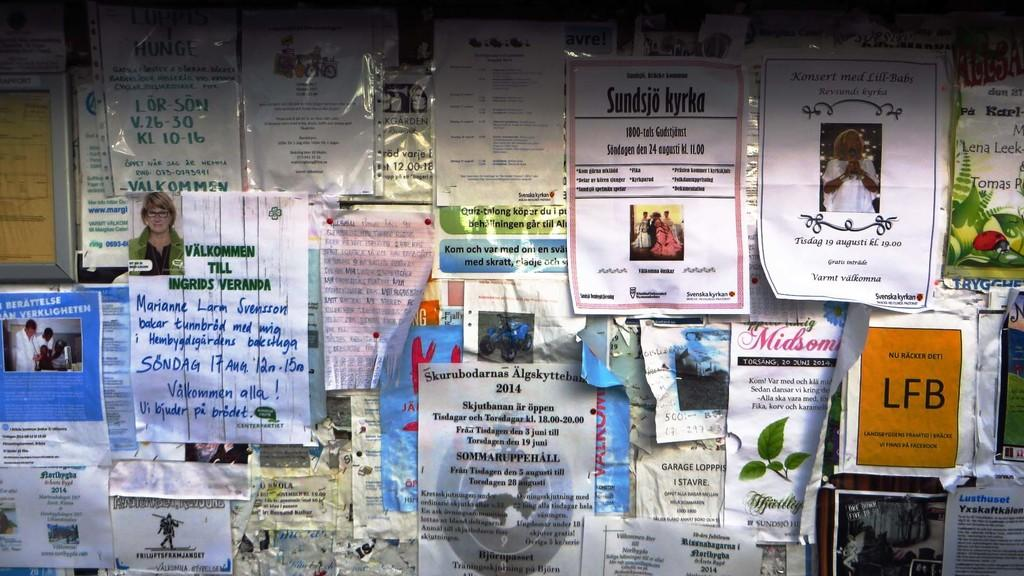What objects can be seen in the image? There are papers and a board placed on the wall in the image. Can you describe the board in the image? The board is placed on the wall in the image. What type of apparatus is used to measure the distance between the papers in the image? There is no apparatus present in the image to measure the distance between the papers. Can you describe the structure of the papers in the image? The papers are flat and rectangular in the image, but there is no specific structure to describe. 